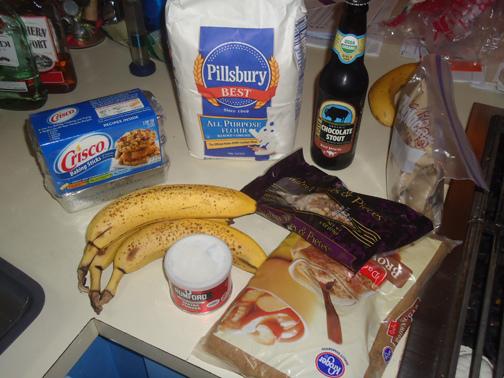What is in the bag?
Write a very short answer. Sugar. How many bananas are visible?
Concise answer only. 3. What is this person getting ready to make?
Short answer required. Banana bread. What is the brand of chocolate?
Write a very short answer. Kroger. Are the bananas laying in a basket?
Quick response, please. No. Is this a lunch?
Quick response, please. No. What section of the store is this found in?
Keep it brief. Baking. What language is the writing on the packages written in?
Be succinct. English. What country is this photo from?
Concise answer only. Usa. What does it say on the glass?
Short answer required. Chocolate stout. What types of beverages are there?
Give a very brief answer. Beer. 